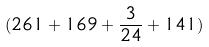<formula> <loc_0><loc_0><loc_500><loc_500>( 2 6 1 + 1 6 9 + \frac { 3 } { 2 4 } + 1 4 1 )</formula> 